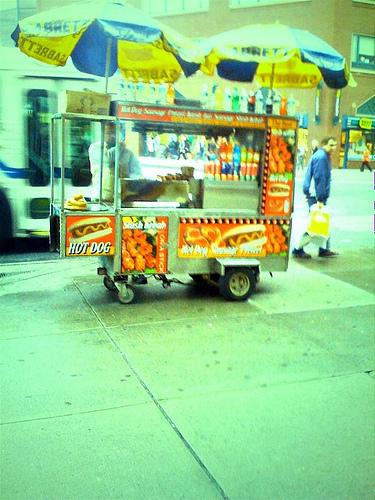What does the vendor sell?
Write a very short answer. Hot dogs. Is it raining?
Quick response, please. No. Does the vendor sell drinks?
Give a very brief answer. Yes. 